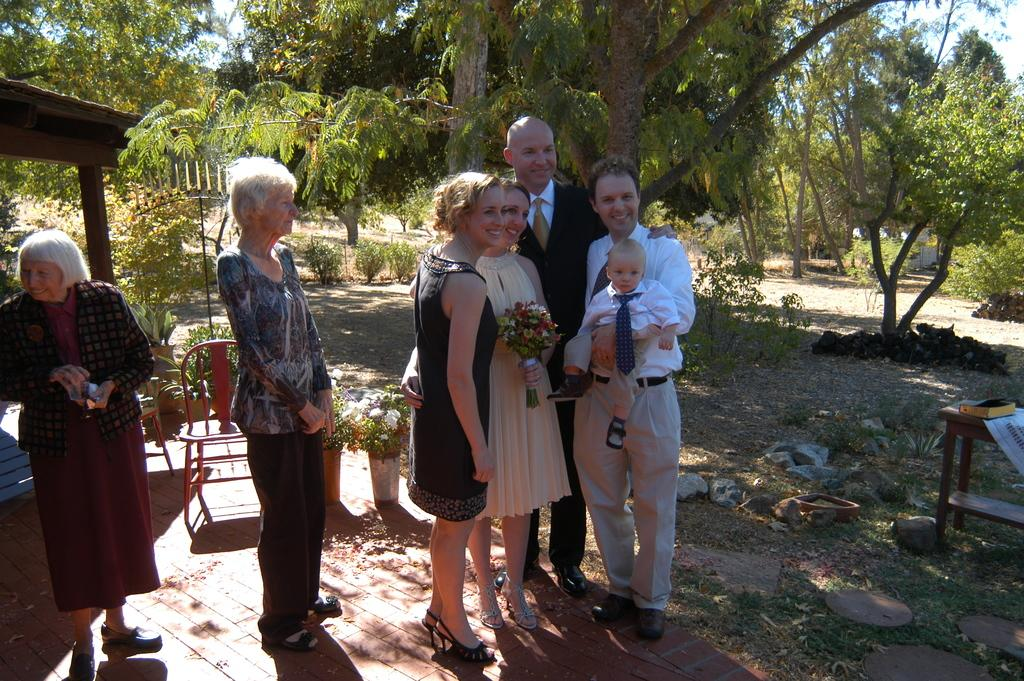How many people are in the image? There is a group of people in the image. What are the people doing in the image? The people are standing on the ground and smiling. What type of vegetation can be seen in the image? There are houseplants, grass, and trees in the image. What type of furniture is present in the image? There is a chair and a table in the image. What object can be seen on the table? There is a book on the table in the image. What is visible in the background of the image? The sky is visible in the background of the image. What type of guitar is being played in the image? There is no guitar present in the image. What verse is being recited by the people in the image? There is no verse being recited in the image; the people are simply smiling. 